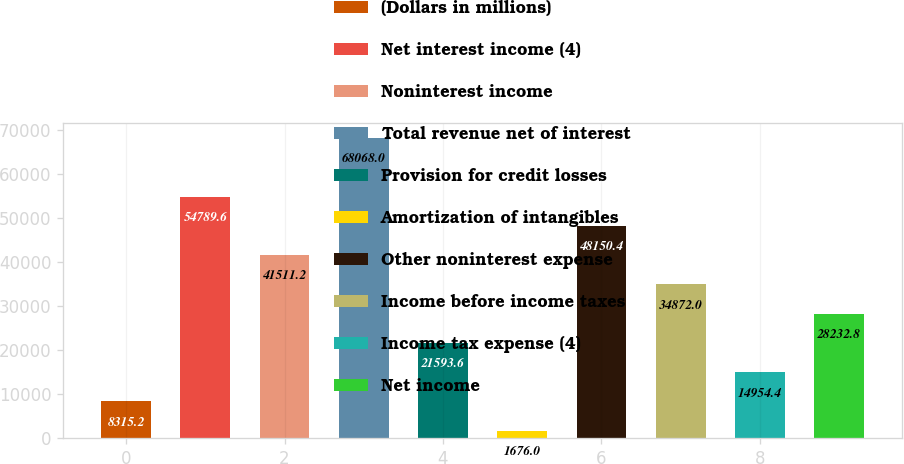Convert chart to OTSL. <chart><loc_0><loc_0><loc_500><loc_500><bar_chart><fcel>(Dollars in millions)<fcel>Net interest income (4)<fcel>Noninterest income<fcel>Total revenue net of interest<fcel>Provision for credit losses<fcel>Amortization of intangibles<fcel>Other noninterest expense<fcel>Income before income taxes<fcel>Income tax expense (4)<fcel>Net income<nl><fcel>8315.2<fcel>54789.6<fcel>41511.2<fcel>68068<fcel>21593.6<fcel>1676<fcel>48150.4<fcel>34872<fcel>14954.4<fcel>28232.8<nl></chart> 